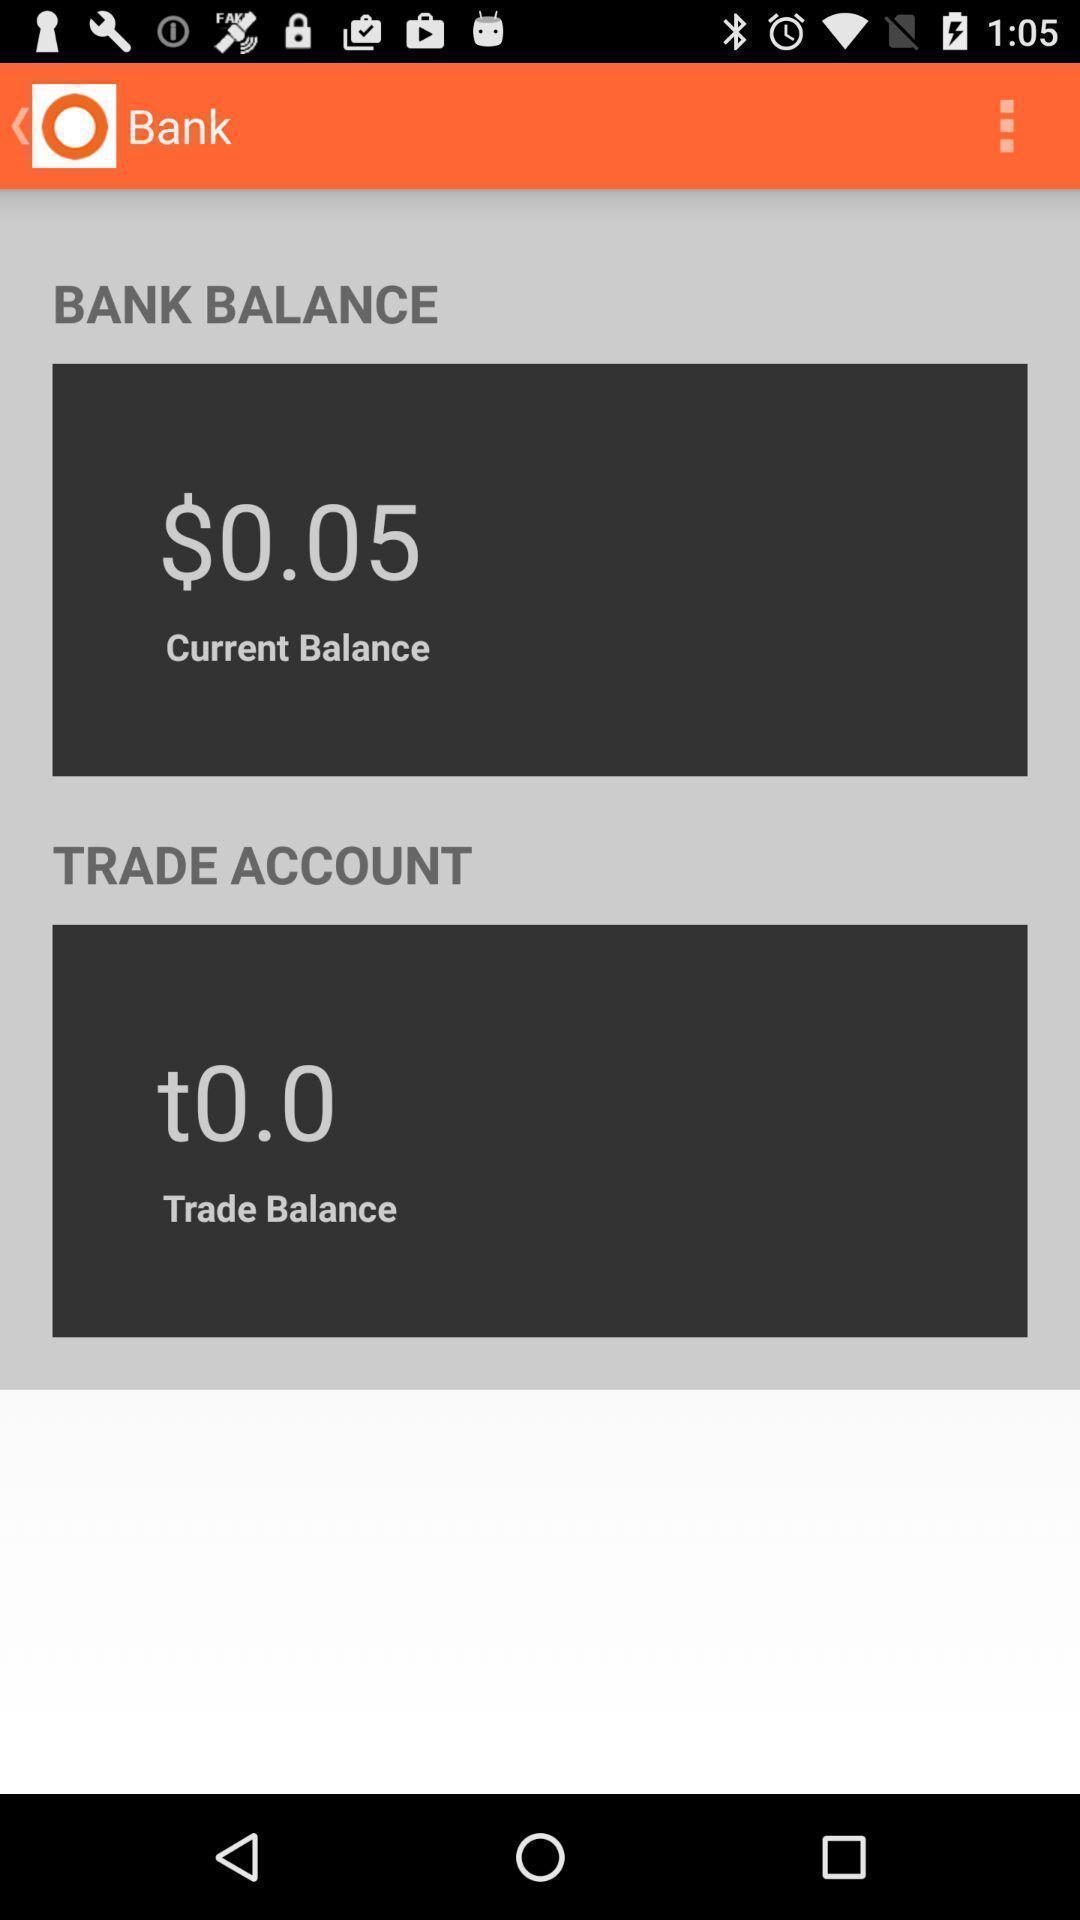Describe this image in words. Screen displaying bank balance and trade account. 